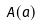Convert formula to latex. <formula><loc_0><loc_0><loc_500><loc_500>A ( a )</formula> 